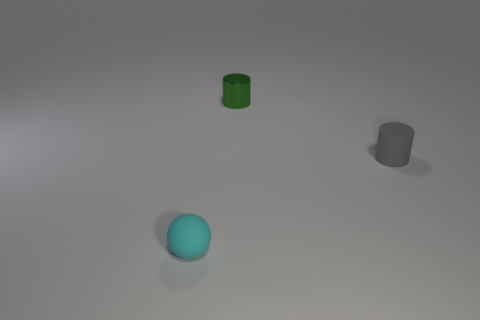Add 1 small green shiny objects. How many objects exist? 4 Subtract all spheres. How many objects are left? 2 Subtract 0 purple blocks. How many objects are left? 3 Subtract all small cyan spheres. Subtract all gray things. How many objects are left? 1 Add 1 small metallic things. How many small metallic things are left? 2 Add 1 large metal cylinders. How many large metal cylinders exist? 1 